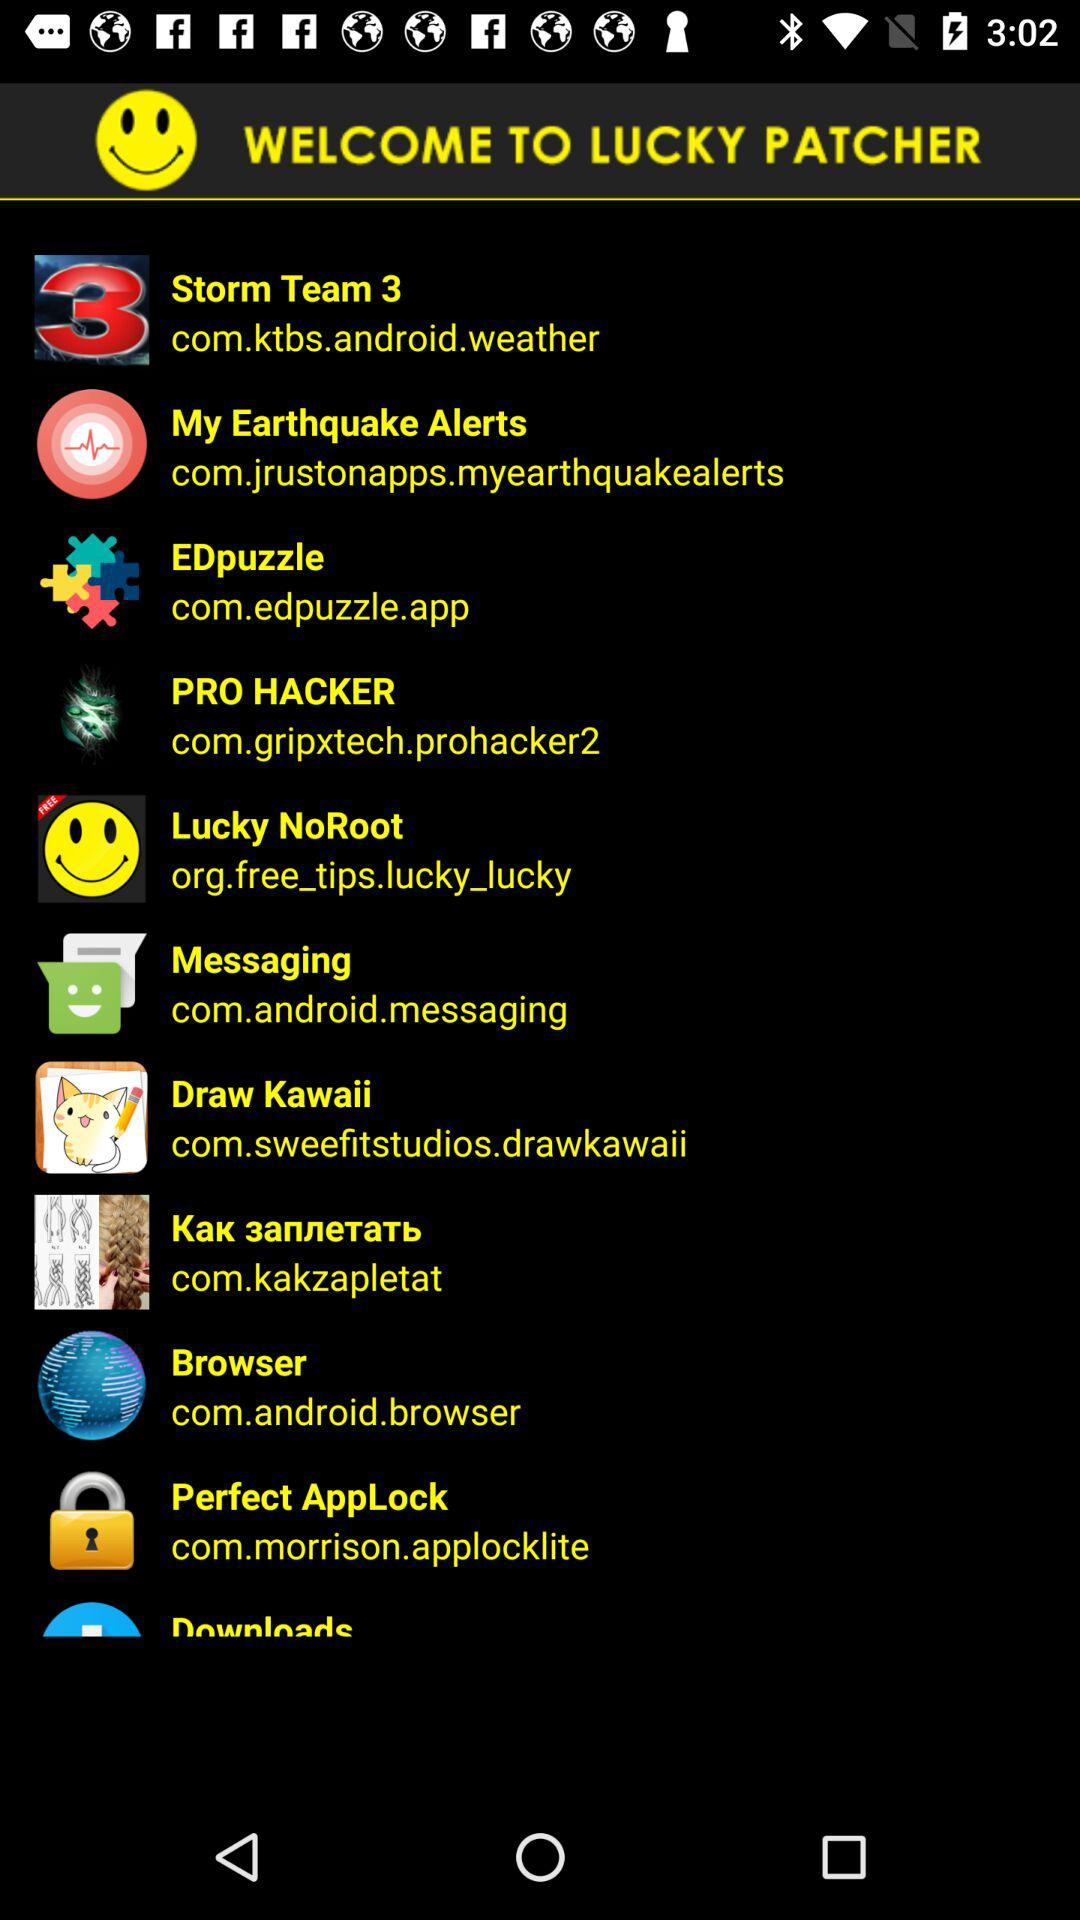What is the application name? The application name is "LUCKY PATCHER". 